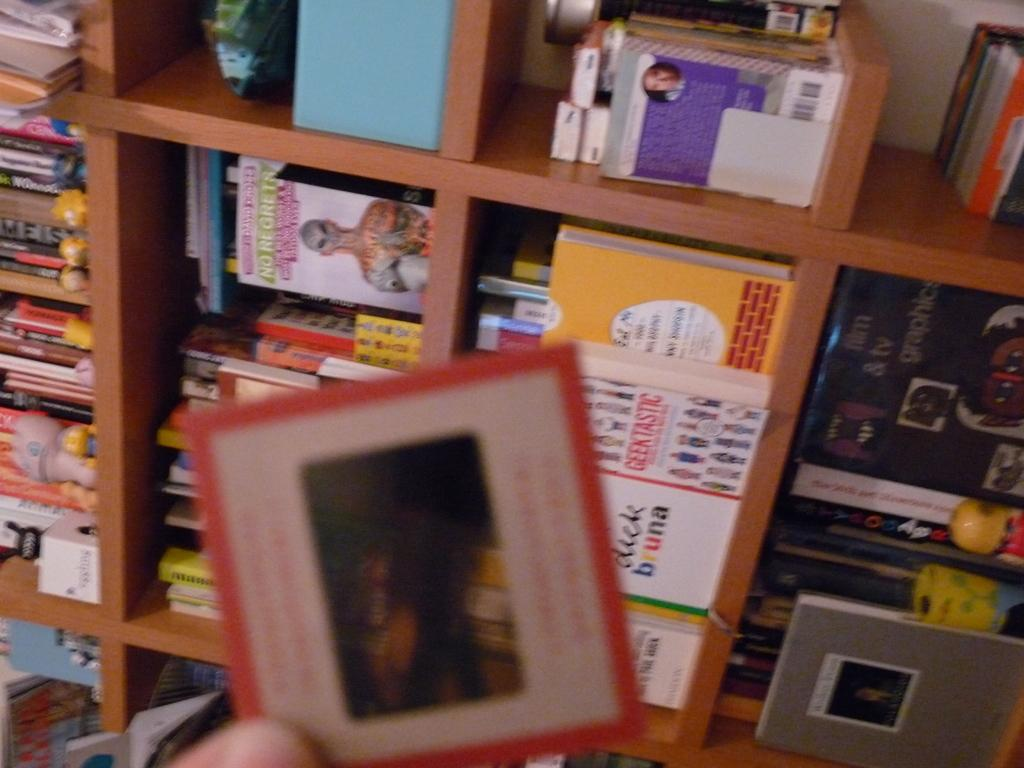<image>
Share a concise interpretation of the image provided. A display of book sits on a large shelf with one being titled Geektastic 